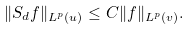<formula> <loc_0><loc_0><loc_500><loc_500>\| S _ { d } f \| _ { L ^ { p } ( u ) } \leq C \| f \| _ { L ^ { p } ( v ) } .</formula> 